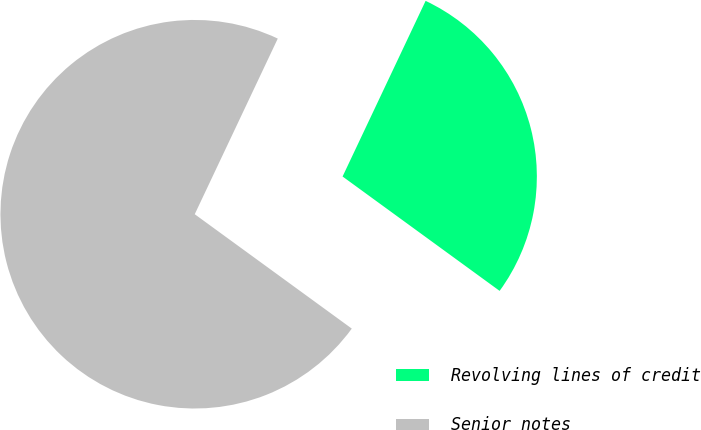<chart> <loc_0><loc_0><loc_500><loc_500><pie_chart><fcel>Revolving lines of credit<fcel>Senior notes<nl><fcel>27.99%<fcel>72.01%<nl></chart> 